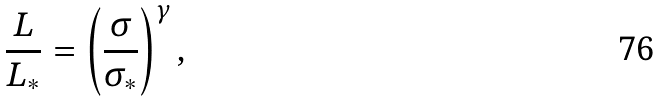<formula> <loc_0><loc_0><loc_500><loc_500>\frac { L } { L _ { * } } = \left ( \frac { \sigma } { \sigma _ { * } } \right ) ^ { \gamma } ,</formula> 